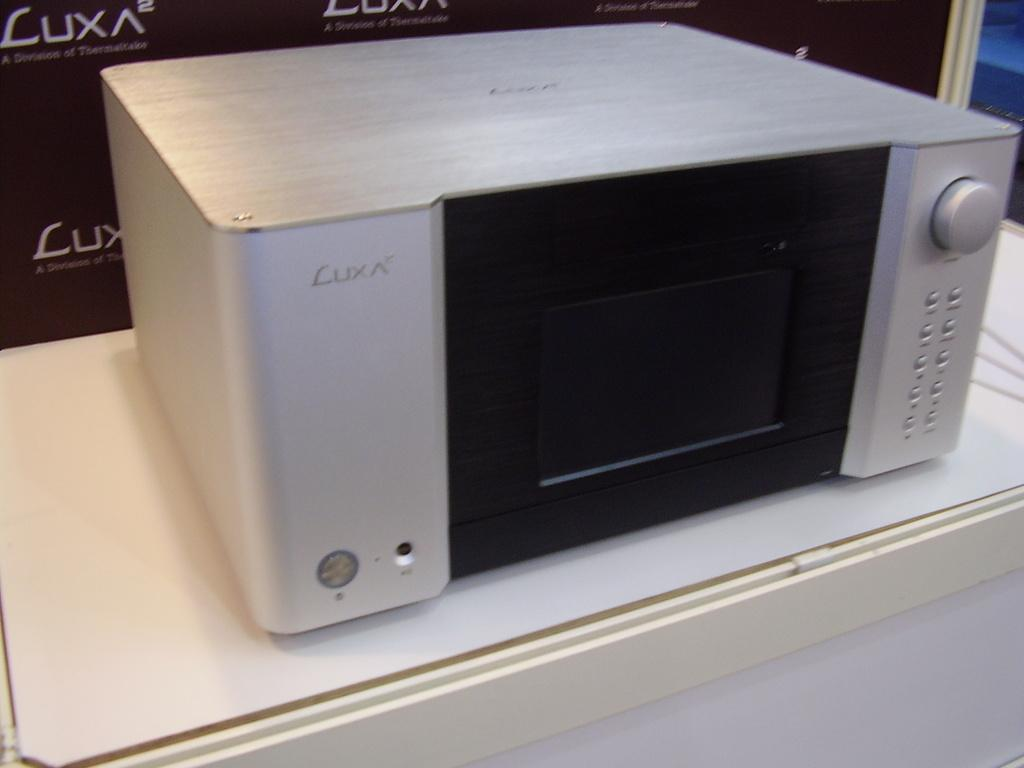<image>
Summarize the visual content of the image. a LUX ^2 silver electronic gadget is on display at a shop 